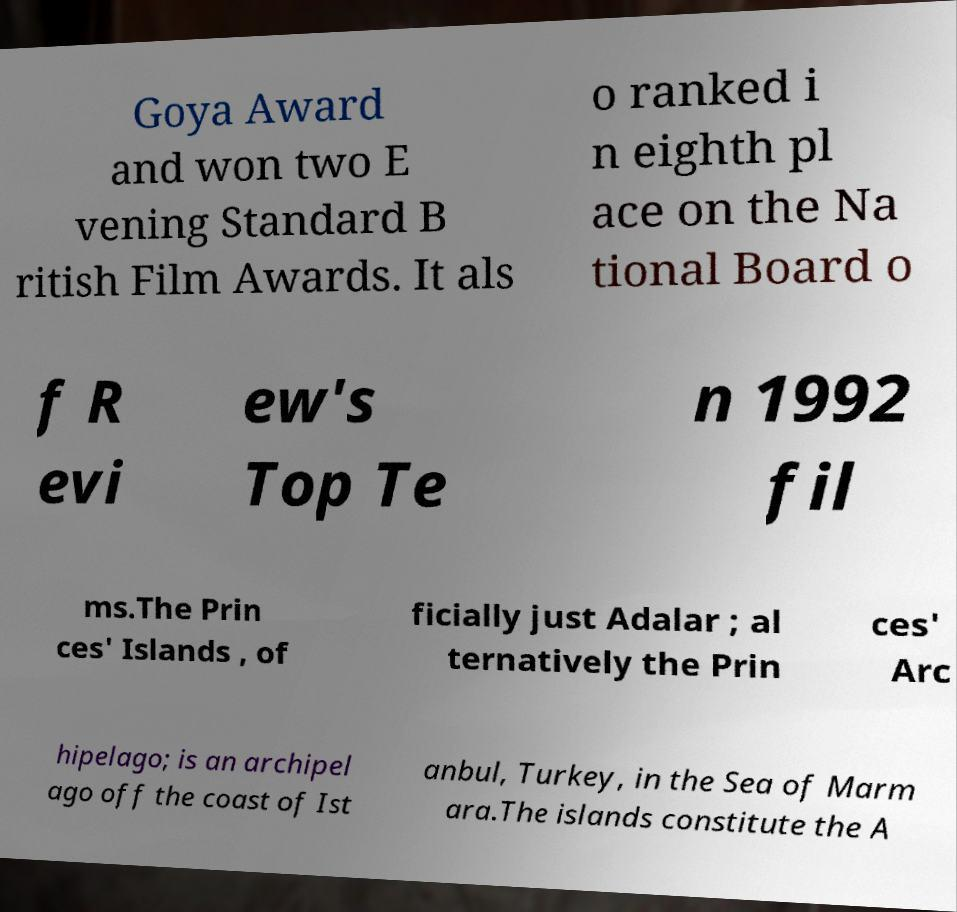Can you accurately transcribe the text from the provided image for me? Goya Award and won two E vening Standard B ritish Film Awards. It als o ranked i n eighth pl ace on the Na tional Board o f R evi ew's Top Te n 1992 fil ms.The Prin ces' Islands , of ficially just Adalar ; al ternatively the Prin ces' Arc hipelago; is an archipel ago off the coast of Ist anbul, Turkey, in the Sea of Marm ara.The islands constitute the A 